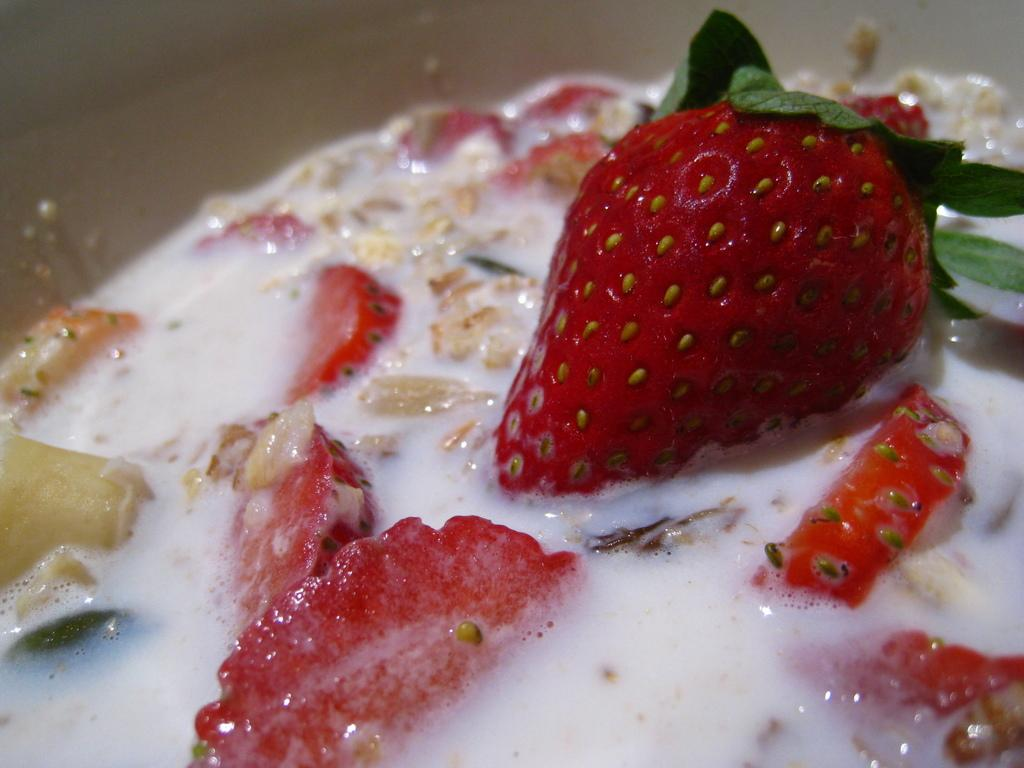What type of fruit is present in the image? There are strawberries in the image. What other food items can be seen in the image? There are other food items in the image, but their specific types are not mentioned in the facts. In what kind of container or object are the food items placed? The food items are in an object, but the specific type of object is not mentioned in the facts. What is the weather like in the image? The facts provided do not mention anything about the weather, so we cannot determine the weather from the image. 